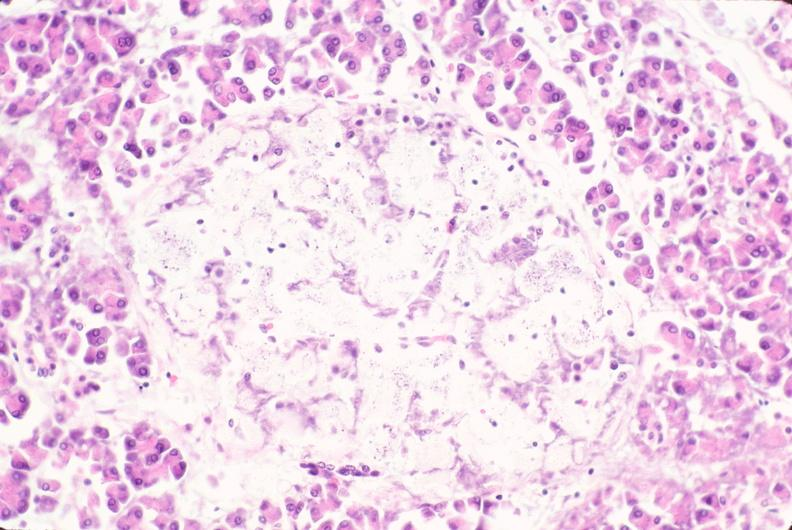s chest and abdomen slide present?
Answer the question using a single word or phrase. No 